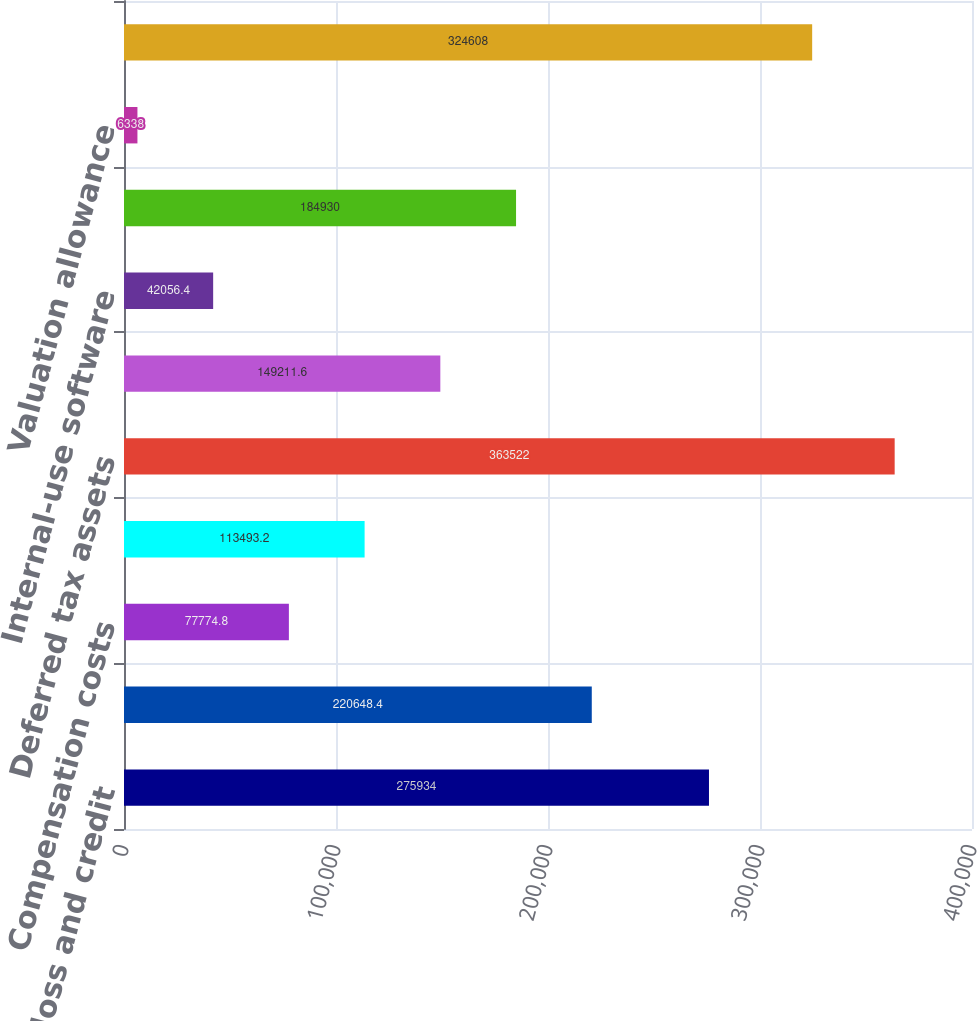<chart> <loc_0><loc_0><loc_500><loc_500><bar_chart><fcel>Net operating loss and credit<fcel>Depreciation and amortization<fcel>Compensation costs<fcel>Other<fcel>Deferred tax assets<fcel>Acquired intangible assets not<fcel>Internal-use software<fcel>Deferred tax liabilities<fcel>Valuation allowance<fcel>Net deferred tax asset and<nl><fcel>275934<fcel>220648<fcel>77774.8<fcel>113493<fcel>363522<fcel>149212<fcel>42056.4<fcel>184930<fcel>6338<fcel>324608<nl></chart> 